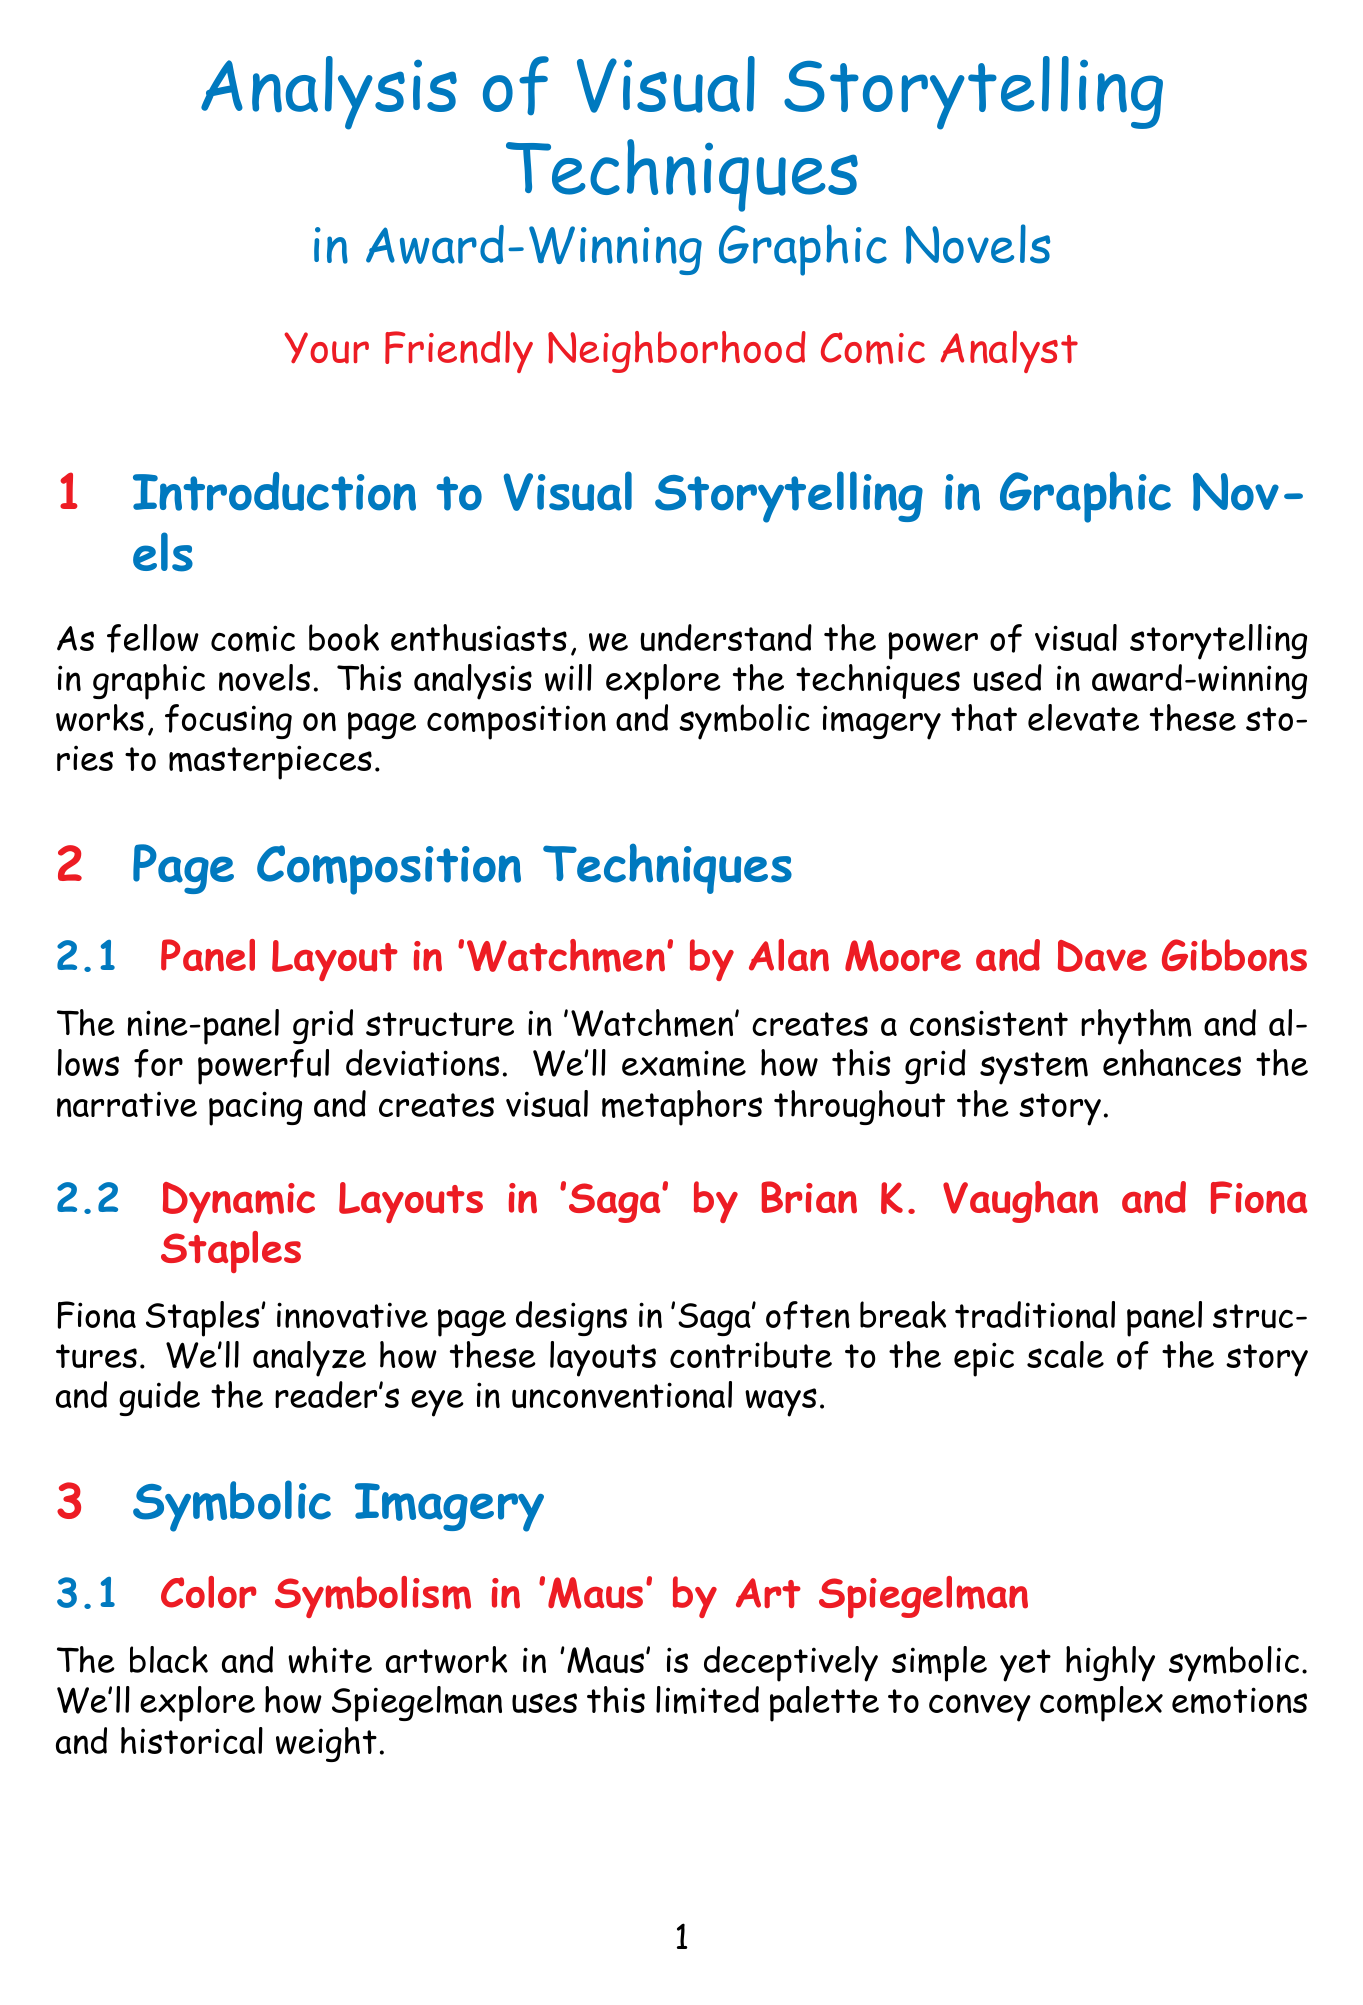What is the main focus of the analysis? The analysis focuses on page composition and symbolic imagery in award-winning graphic novels.
Answer: page composition and symbolic imagery Who are the authors of 'Maus'? The author of 'Maus' is Art Spiegelman.
Answer: Art Spiegelman What unique panel structure is used in 'Watchmen'? The unique panel structure used in 'Watchmen' is a nine-panel grid.
Answer: nine-panel grid In which section are recurring motifs discussed? Recurring motifs are discussed in the Symbolic Imagery section.
Answer: Symbolic Imagery What innovative technique does Shaun Tan use in 'The Arrival'? Shaun Tan uses silent storytelling in 'The Arrival'.
Answer: silent storytelling Which graphic novel features dynamic fight scenes? 'Scott Pilgrim' features dynamic fight scenes.
Answer: 'Scott Pilgrim' Who are the creators of 'Daytripper'? The creators of 'Daytripper' are Fábio Moon and Gabriel Bá.
Answer: Fábio Moon and Gabriel Bá What does the section on Integration of Text and Image cover? The section on Integration of Text and Image covers how text and image are combined in graphic novels.
Answer: combination of text and image What is the recommended resource that provides insights into comic theory? The recommended resource is "Understanding Comics" by Scott McCloud.
Answer: "Understanding Comics" by Scott McCloud 